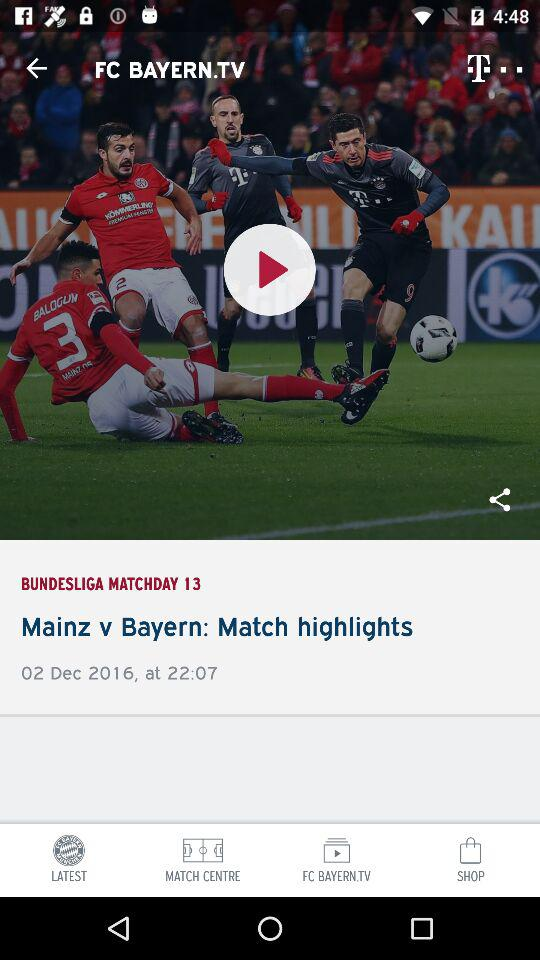What is the date of match highlights? The date is December 02, 2016. 